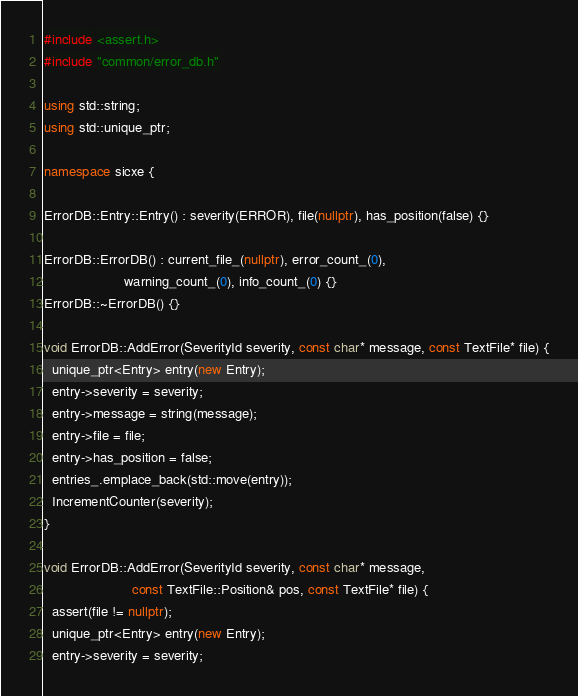<code> <loc_0><loc_0><loc_500><loc_500><_C++_>#include <assert.h>
#include "common/error_db.h"

using std::string;
using std::unique_ptr;

namespace sicxe {

ErrorDB::Entry::Entry() : severity(ERROR), file(nullptr), has_position(false) {}

ErrorDB::ErrorDB() : current_file_(nullptr), error_count_(0),
                     warning_count_(0), info_count_(0) {}
ErrorDB::~ErrorDB() {}

void ErrorDB::AddError(SeverityId severity, const char* message, const TextFile* file) {
  unique_ptr<Entry> entry(new Entry);
  entry->severity = severity;
  entry->message = string(message);
  entry->file = file;
  entry->has_position = false;
  entries_.emplace_back(std::move(entry));
  IncrementCounter(severity);
}

void ErrorDB::AddError(SeverityId severity, const char* message,
                       const TextFile::Position& pos, const TextFile* file) {
  assert(file != nullptr);
  unique_ptr<Entry> entry(new Entry);
  entry->severity = severity;</code> 